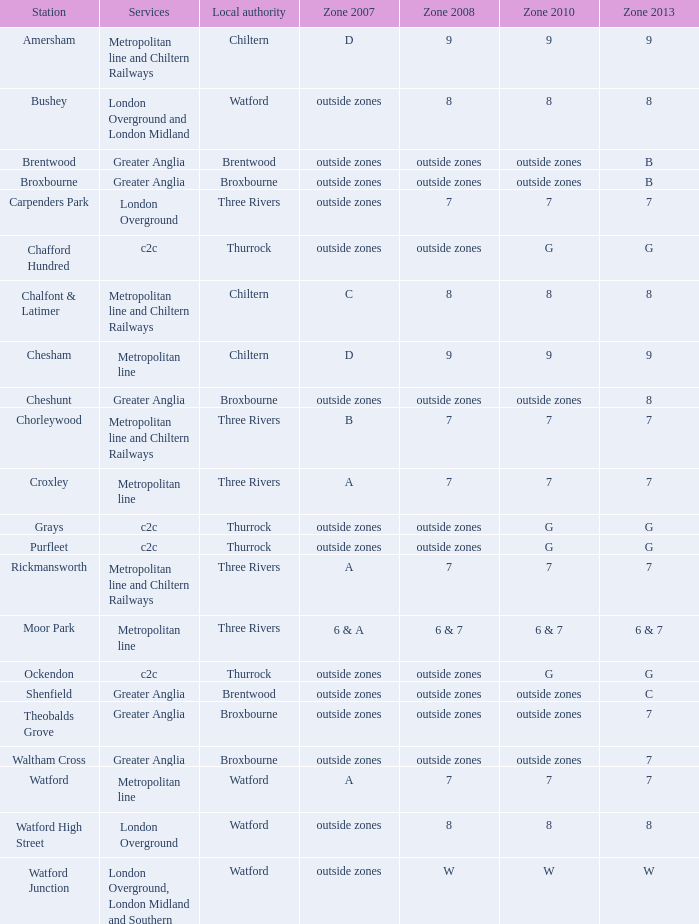Identify the station that falls under zone 2008 with a rating of 8, is not within any zones in zone 2007, and is connected by the london overground services. Watford High Street. 